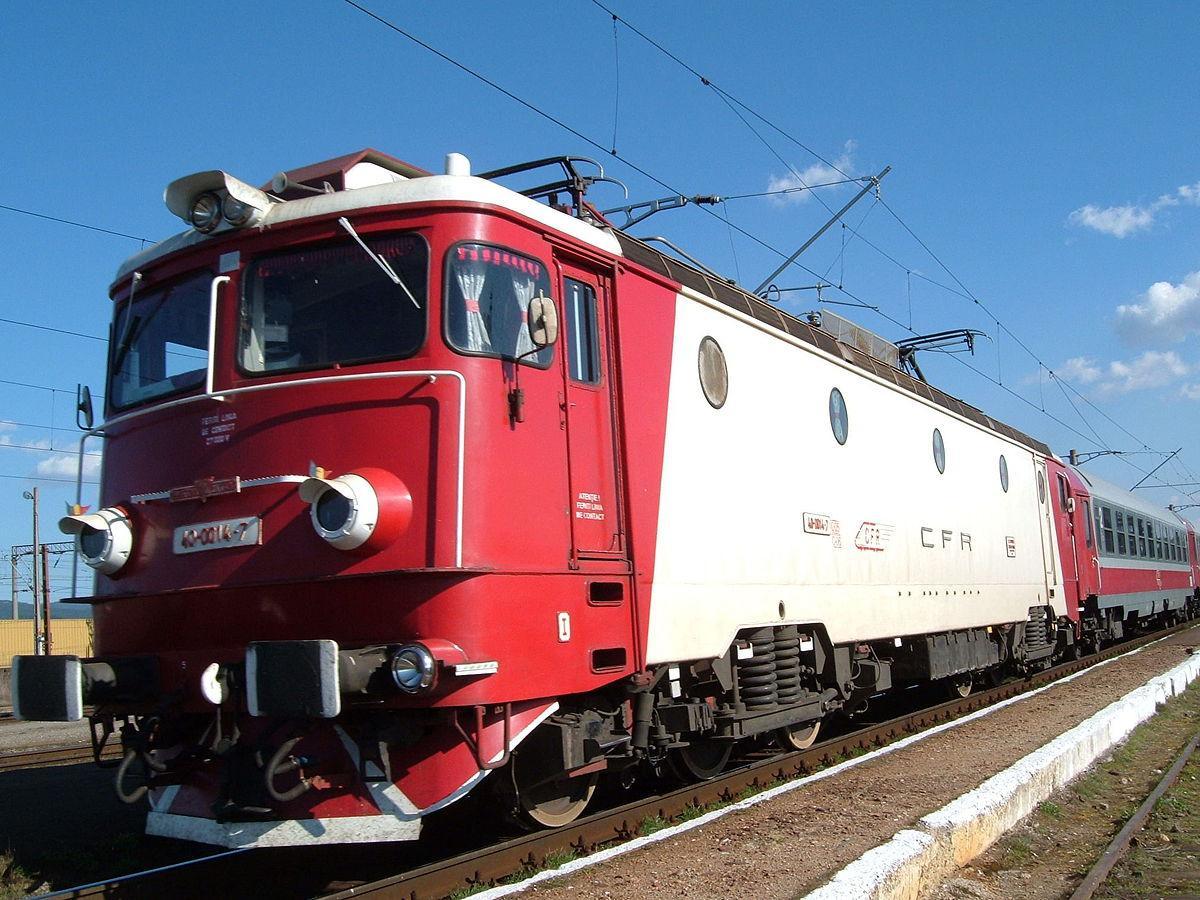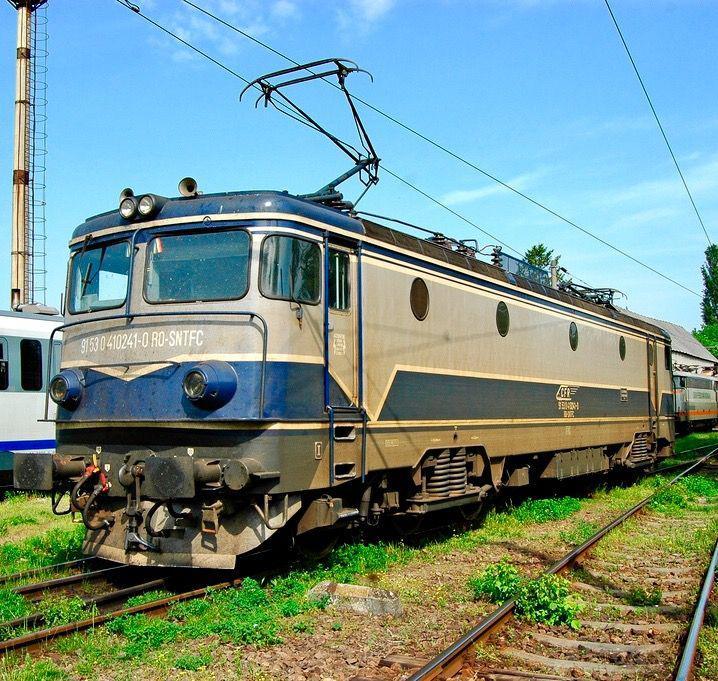The first image is the image on the left, the second image is the image on the right. For the images shown, is this caption "the train in the image on the left does not have any round windows" true? Answer yes or no. No. The first image is the image on the left, the second image is the image on the right. Examine the images to the left and right. Is the description "One image shows a red and white train angled to face leftward." accurate? Answer yes or no. Yes. 